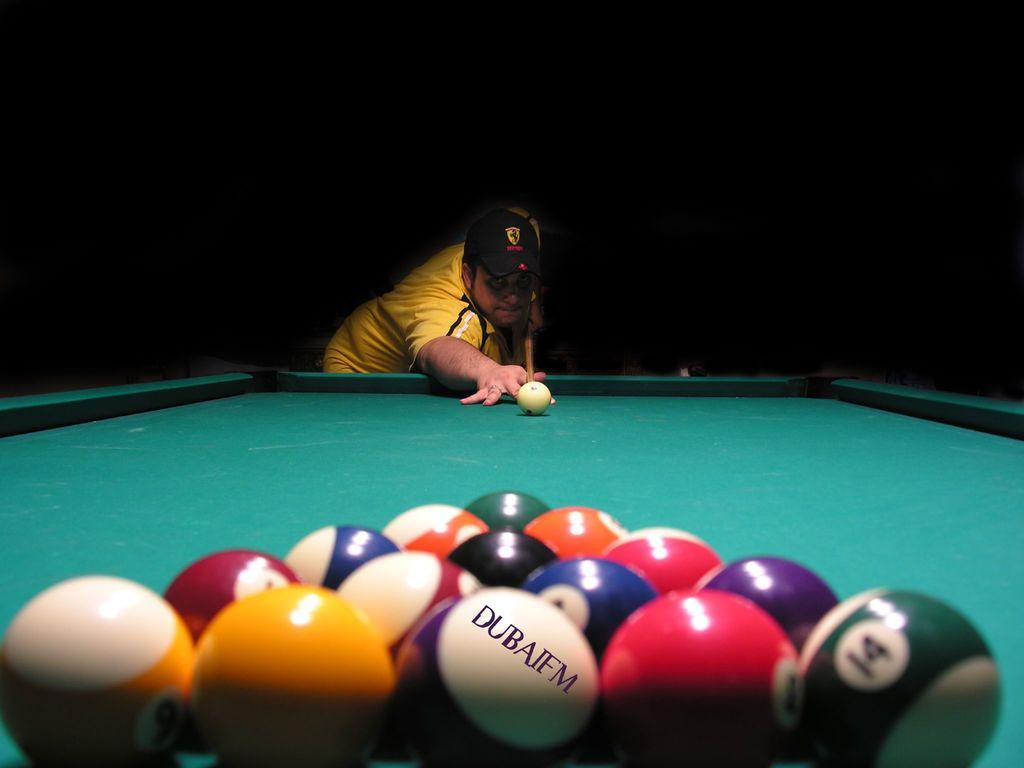What objects are present in the image related to the game of snooker? There is a group of snooker balls and a snooker board in the image. What activity is the man in the image engaged in? The man is playing snooker in the image. What tool is the man using to play snooker? The man is holding a stick (cue) in his hands. What type of flowers can be seen growing on the snooker board in the image? There are no flowers present on the snooker board in the image; it is a game table for playing snooker. 